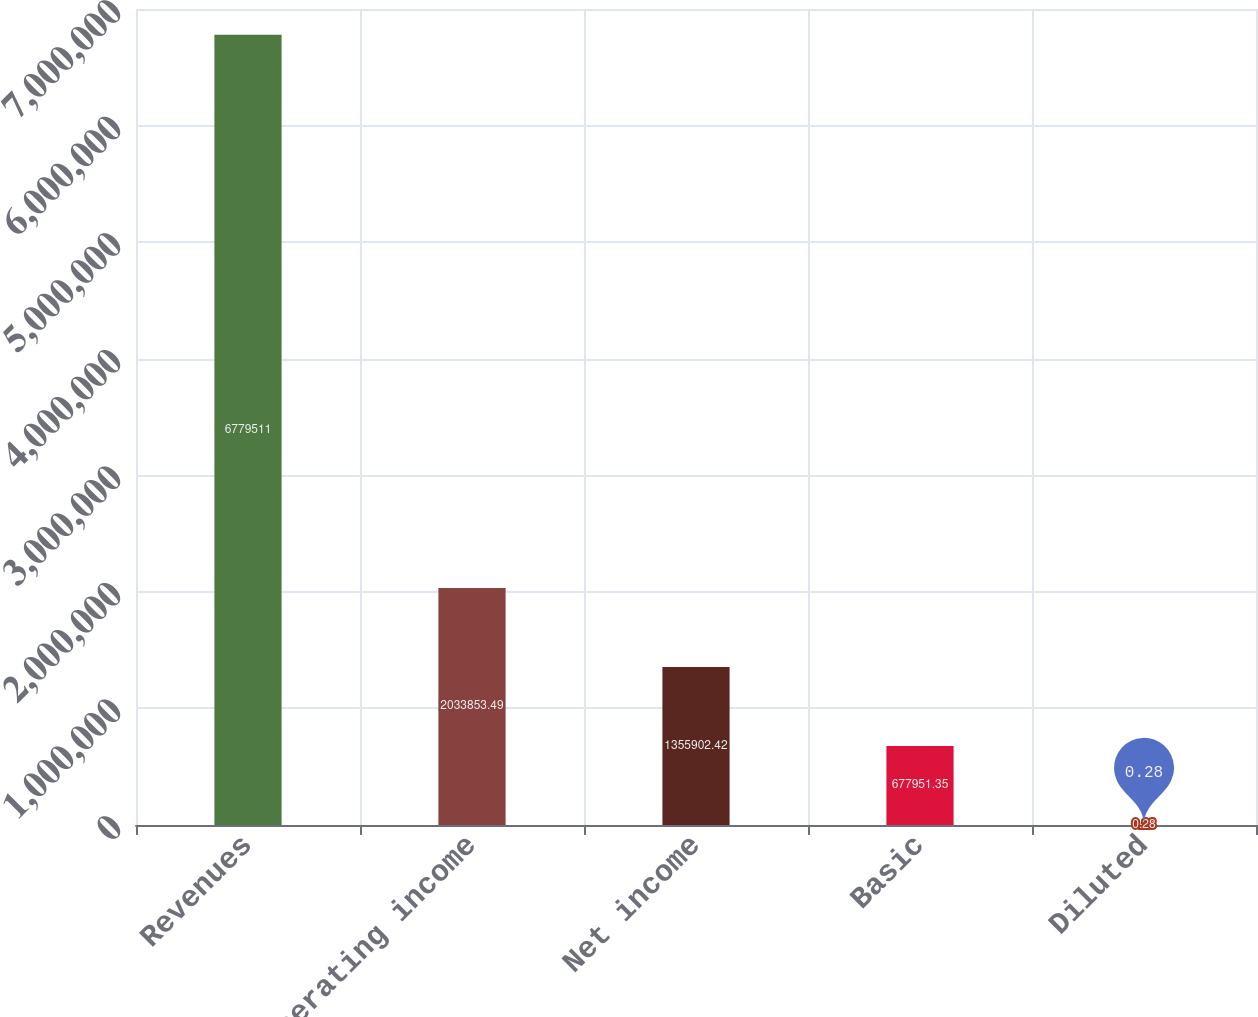Convert chart. <chart><loc_0><loc_0><loc_500><loc_500><bar_chart><fcel>Revenues<fcel>Operating income<fcel>Net income<fcel>Basic<fcel>Diluted<nl><fcel>6.77951e+06<fcel>2.03385e+06<fcel>1.3559e+06<fcel>677951<fcel>0.28<nl></chart> 